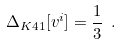Convert formula to latex. <formula><loc_0><loc_0><loc_500><loc_500>\Delta _ { K 4 1 } [ v ^ { i } ] = \frac { 1 } { 3 } \ .</formula> 